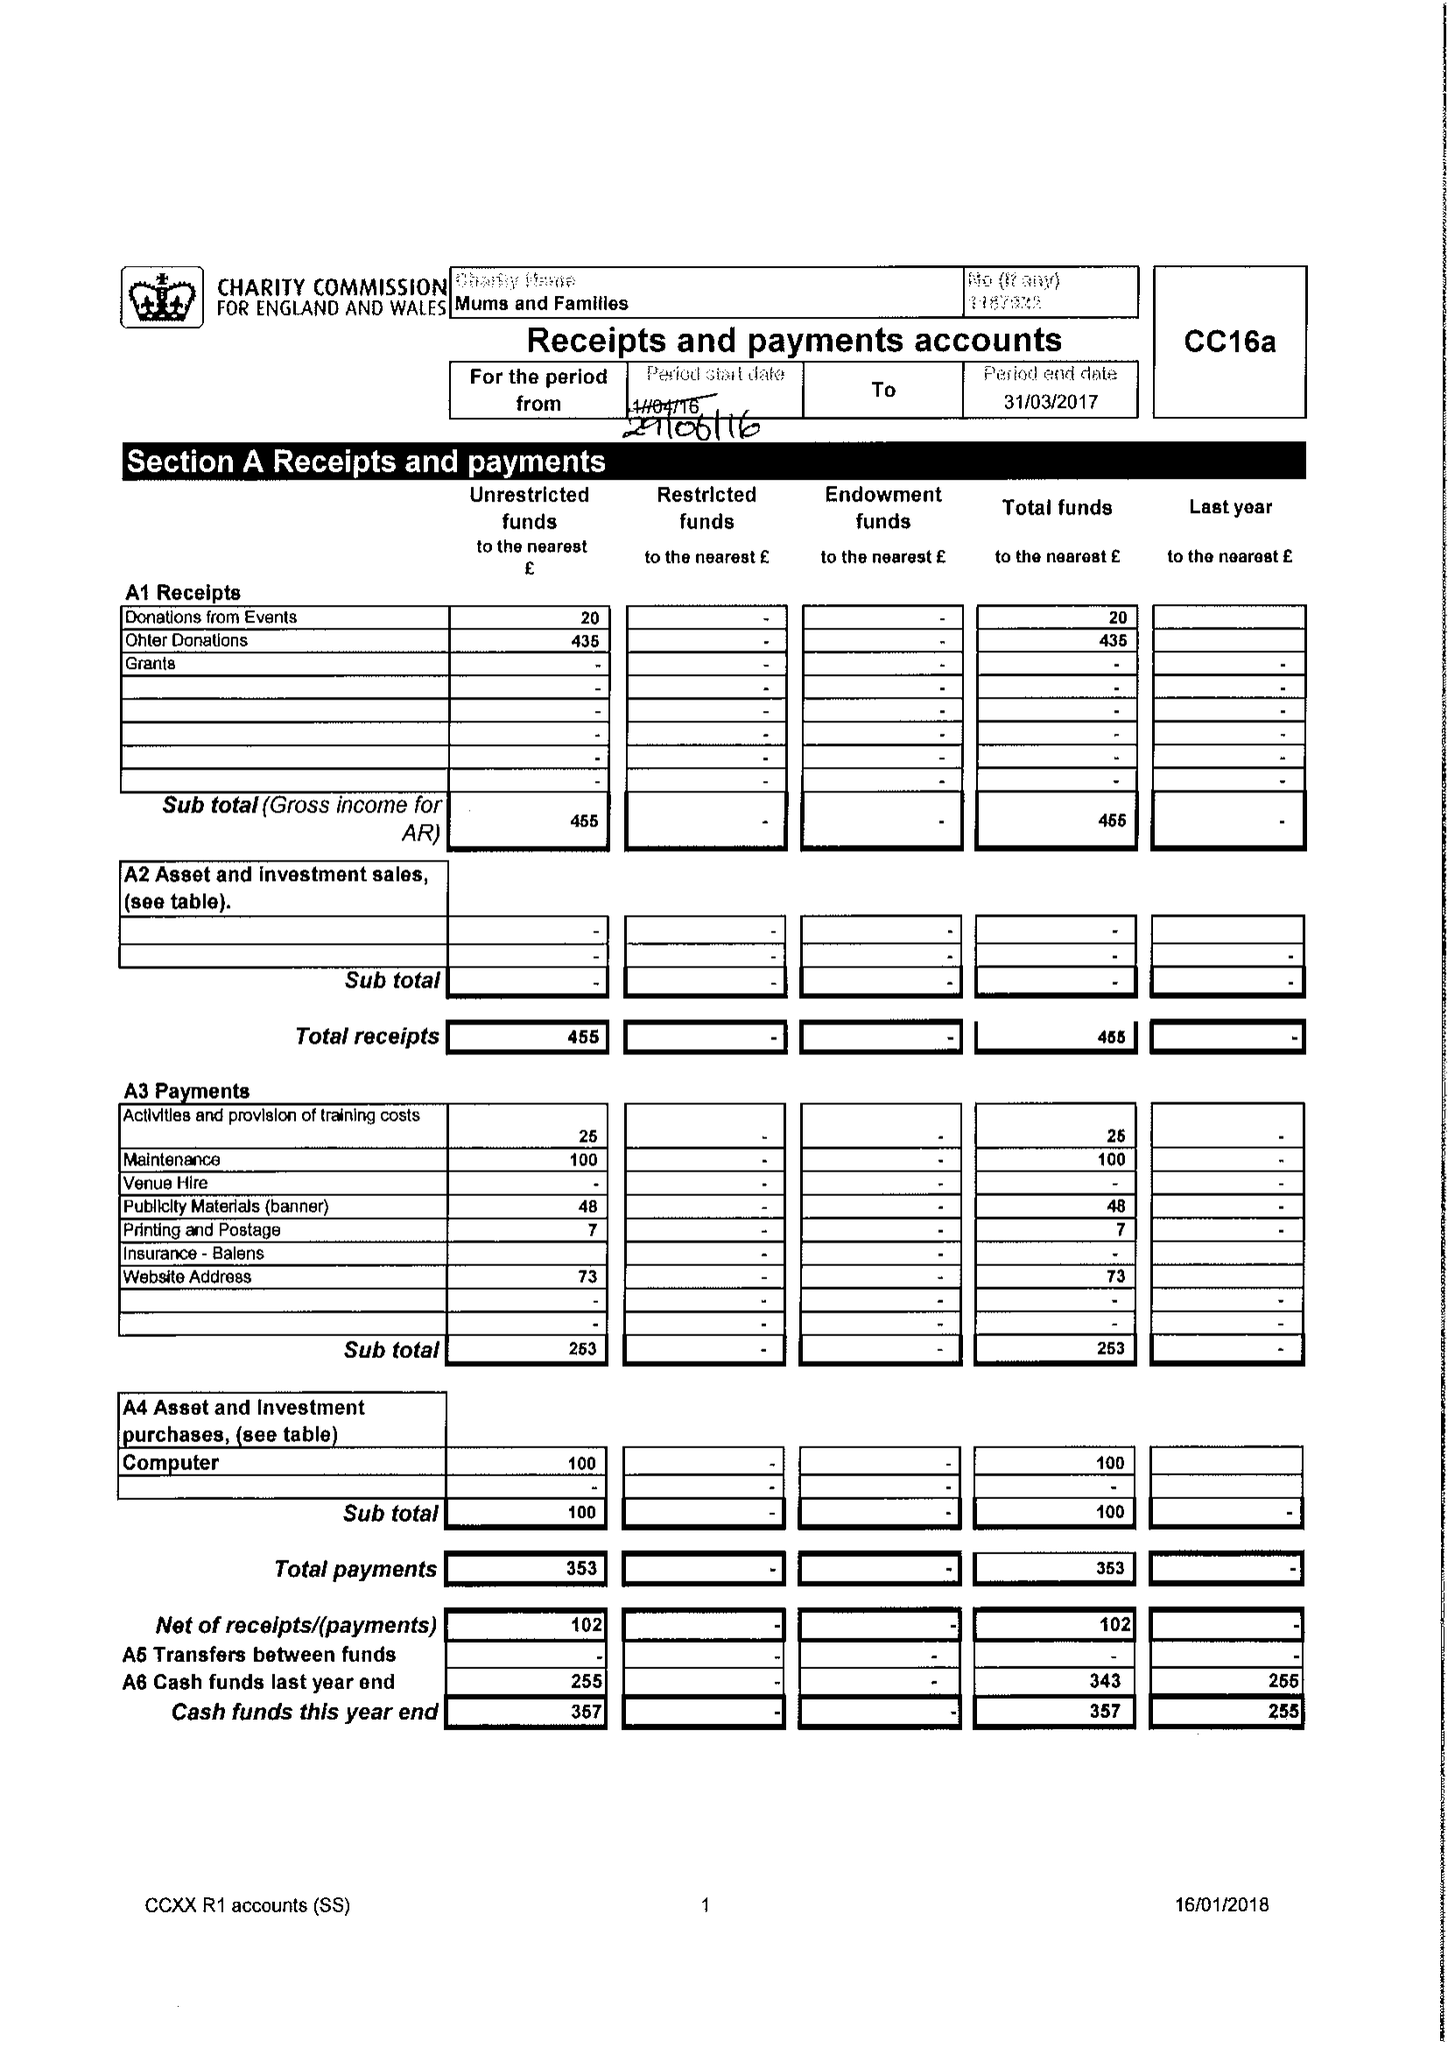What is the value for the charity_name?
Answer the question using a single word or phrase. Mums and Families 